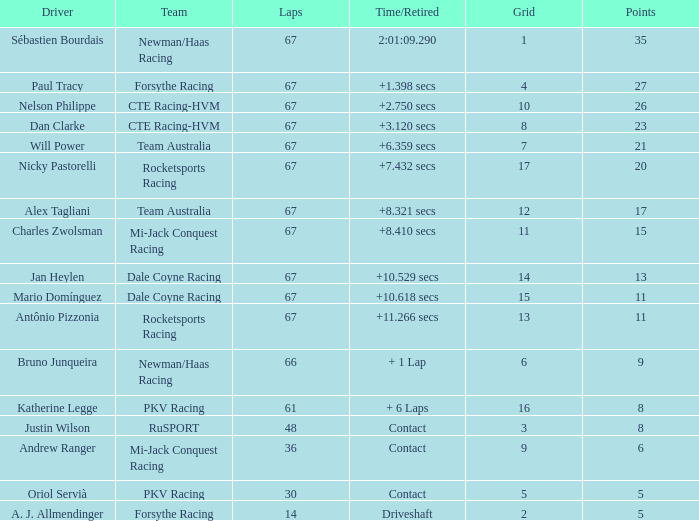What is the average number of laps for alex tagliani when he scores over 17 points? None. 